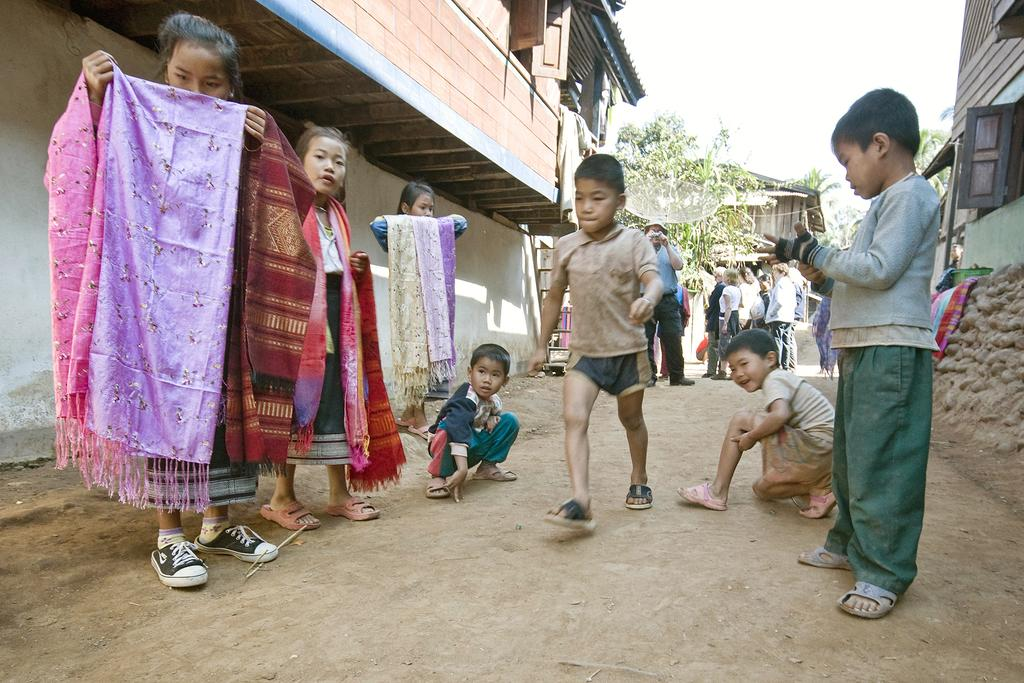How many people are present in the image? There are people in the image, but the exact number is not specified. What are the people holding in the image? Three people are holding clothes in the image. What type of structures can be seen in the image? There are houses and walls visible in the image. What type of vegetation is present in the image? There are trees in the image. What is visible in the background of the image? The sky is visible in the background of the image. What type of bears can be seen offering items in the image? There are no bears present in the image, and therefore no such activity can be observed. What type of store can be seen in the image? There is no store present in the image. 